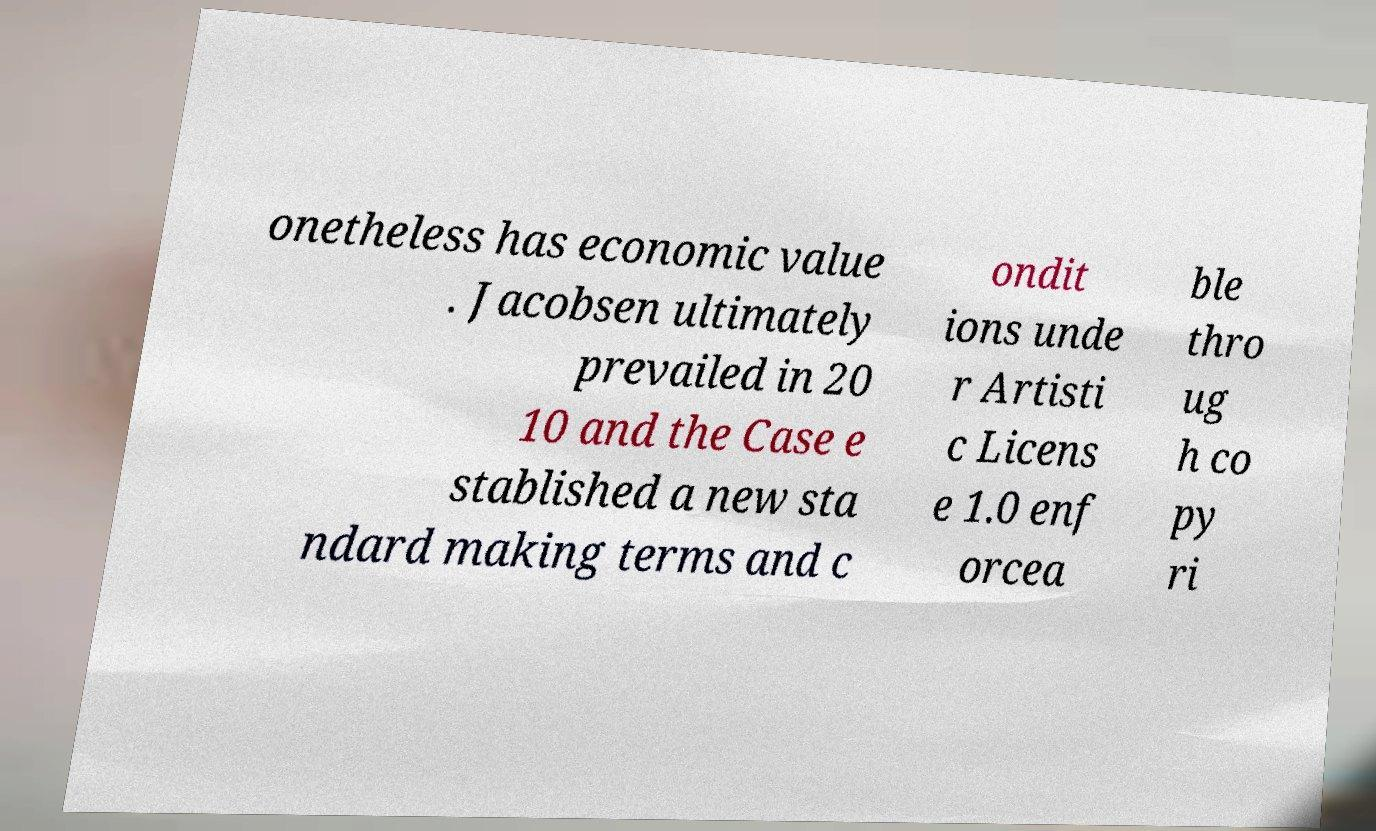Can you read and provide the text displayed in the image?This photo seems to have some interesting text. Can you extract and type it out for me? onetheless has economic value . Jacobsen ultimately prevailed in 20 10 and the Case e stablished a new sta ndard making terms and c ondit ions unde r Artisti c Licens e 1.0 enf orcea ble thro ug h co py ri 